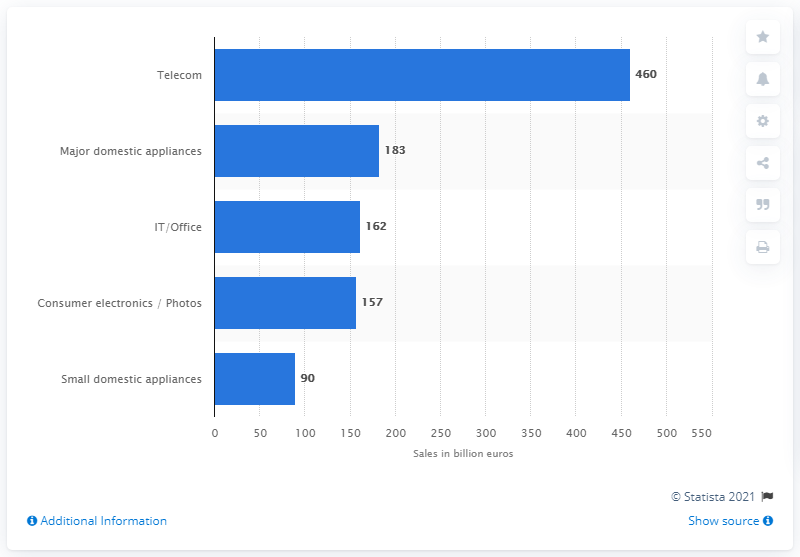Specify some key components in this picture. The forecast value of telecommunications goods worldwide in 2019 was 460 billion U.S. dollars. 